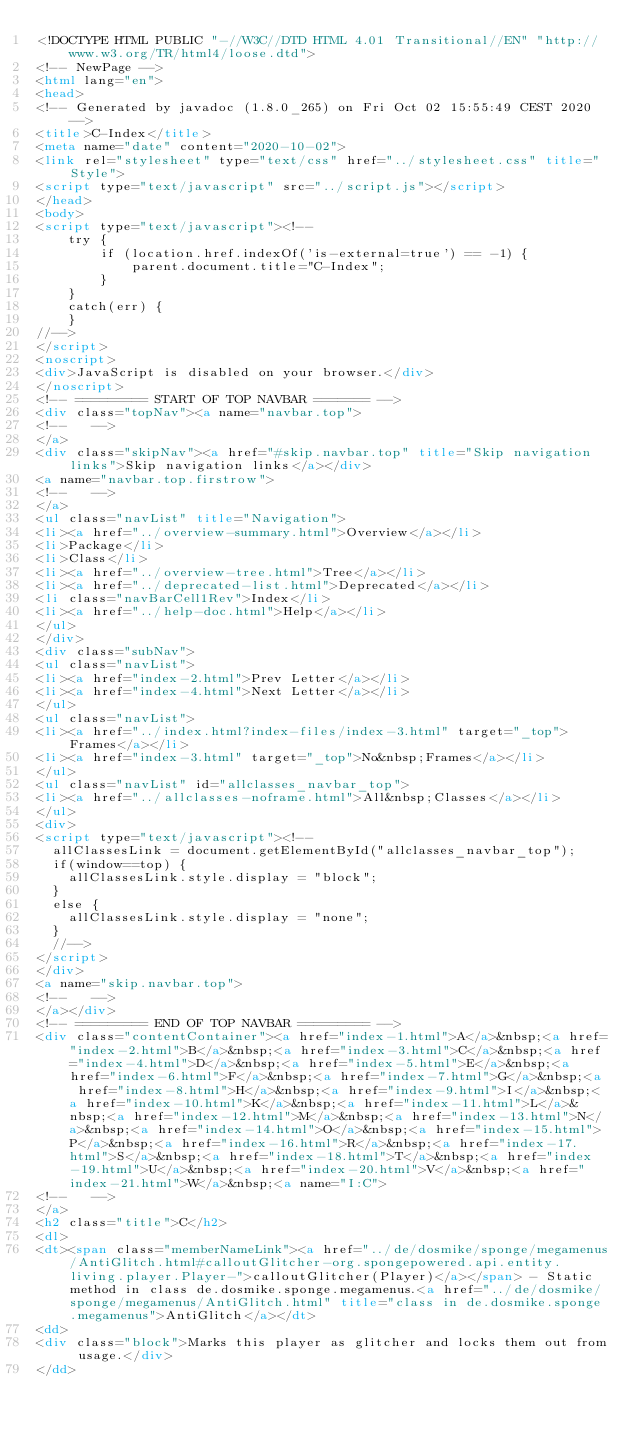<code> <loc_0><loc_0><loc_500><loc_500><_HTML_><!DOCTYPE HTML PUBLIC "-//W3C//DTD HTML 4.01 Transitional//EN" "http://www.w3.org/TR/html4/loose.dtd">
<!-- NewPage -->
<html lang="en">
<head>
<!-- Generated by javadoc (1.8.0_265) on Fri Oct 02 15:55:49 CEST 2020 -->
<title>C-Index</title>
<meta name="date" content="2020-10-02">
<link rel="stylesheet" type="text/css" href="../stylesheet.css" title="Style">
<script type="text/javascript" src="../script.js"></script>
</head>
<body>
<script type="text/javascript"><!--
    try {
        if (location.href.indexOf('is-external=true') == -1) {
            parent.document.title="C-Index";
        }
    }
    catch(err) {
    }
//-->
</script>
<noscript>
<div>JavaScript is disabled on your browser.</div>
</noscript>
<!-- ========= START OF TOP NAVBAR ======= -->
<div class="topNav"><a name="navbar.top">
<!--   -->
</a>
<div class="skipNav"><a href="#skip.navbar.top" title="Skip navigation links">Skip navigation links</a></div>
<a name="navbar.top.firstrow">
<!--   -->
</a>
<ul class="navList" title="Navigation">
<li><a href="../overview-summary.html">Overview</a></li>
<li>Package</li>
<li>Class</li>
<li><a href="../overview-tree.html">Tree</a></li>
<li><a href="../deprecated-list.html">Deprecated</a></li>
<li class="navBarCell1Rev">Index</li>
<li><a href="../help-doc.html">Help</a></li>
</ul>
</div>
<div class="subNav">
<ul class="navList">
<li><a href="index-2.html">Prev Letter</a></li>
<li><a href="index-4.html">Next Letter</a></li>
</ul>
<ul class="navList">
<li><a href="../index.html?index-files/index-3.html" target="_top">Frames</a></li>
<li><a href="index-3.html" target="_top">No&nbsp;Frames</a></li>
</ul>
<ul class="navList" id="allclasses_navbar_top">
<li><a href="../allclasses-noframe.html">All&nbsp;Classes</a></li>
</ul>
<div>
<script type="text/javascript"><!--
  allClassesLink = document.getElementById("allclasses_navbar_top");
  if(window==top) {
    allClassesLink.style.display = "block";
  }
  else {
    allClassesLink.style.display = "none";
  }
  //-->
</script>
</div>
<a name="skip.navbar.top">
<!--   -->
</a></div>
<!-- ========= END OF TOP NAVBAR ========= -->
<div class="contentContainer"><a href="index-1.html">A</a>&nbsp;<a href="index-2.html">B</a>&nbsp;<a href="index-3.html">C</a>&nbsp;<a href="index-4.html">D</a>&nbsp;<a href="index-5.html">E</a>&nbsp;<a href="index-6.html">F</a>&nbsp;<a href="index-7.html">G</a>&nbsp;<a href="index-8.html">H</a>&nbsp;<a href="index-9.html">I</a>&nbsp;<a href="index-10.html">K</a>&nbsp;<a href="index-11.html">L</a>&nbsp;<a href="index-12.html">M</a>&nbsp;<a href="index-13.html">N</a>&nbsp;<a href="index-14.html">O</a>&nbsp;<a href="index-15.html">P</a>&nbsp;<a href="index-16.html">R</a>&nbsp;<a href="index-17.html">S</a>&nbsp;<a href="index-18.html">T</a>&nbsp;<a href="index-19.html">U</a>&nbsp;<a href="index-20.html">V</a>&nbsp;<a href="index-21.html">W</a>&nbsp;<a name="I:C">
<!--   -->
</a>
<h2 class="title">C</h2>
<dl>
<dt><span class="memberNameLink"><a href="../de/dosmike/sponge/megamenus/AntiGlitch.html#calloutGlitcher-org.spongepowered.api.entity.living.player.Player-">calloutGlitcher(Player)</a></span> - Static method in class de.dosmike.sponge.megamenus.<a href="../de/dosmike/sponge/megamenus/AntiGlitch.html" title="class in de.dosmike.sponge.megamenus">AntiGlitch</a></dt>
<dd>
<div class="block">Marks this player as glitcher and locks them out from usage.</div>
</dd></code> 